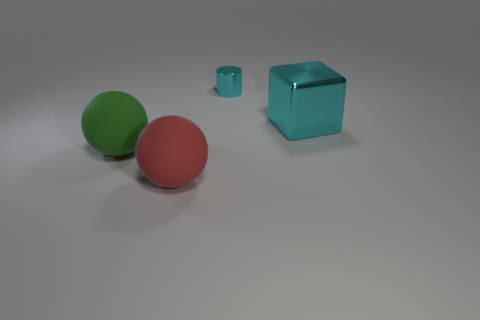Is the big metal object the same color as the tiny thing?
Your response must be concise. Yes. Is there any other thing that has the same size as the cyan metal cylinder?
Offer a very short reply. No. Is there any other thing that has the same shape as the tiny cyan thing?
Offer a very short reply. No. What size is the green sphere?
Your answer should be compact. Large. What color is the object that is on the left side of the large cyan metallic block and behind the green matte object?
Keep it short and to the point. Cyan. Are there more green matte spheres than brown metal cubes?
Make the answer very short. Yes. What number of objects are big cyan shiny blocks or big objects that are on the left side of the metallic cube?
Your answer should be compact. 3. Do the cyan cylinder and the metallic cube have the same size?
Keep it short and to the point. No. Are there any large matte objects behind the large red sphere?
Offer a very short reply. Yes. What size is the object that is both on the left side of the big cyan cube and on the right side of the red matte sphere?
Keep it short and to the point. Small. 